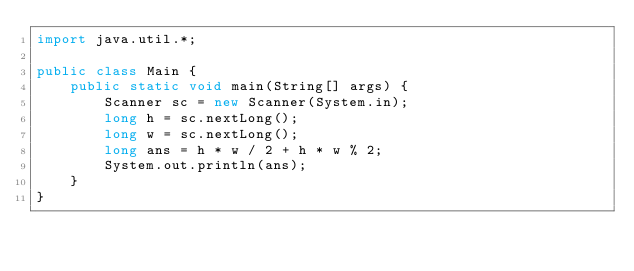Convert code to text. <code><loc_0><loc_0><loc_500><loc_500><_Java_>import java.util.*;

public class Main {
    public static void main(String[] args) {
        Scanner sc = new Scanner(System.in);
        long h = sc.nextLong();
        long w = sc.nextLong();
        long ans = h * w / 2 + h * w % 2;
        System.out.println(ans);
    }
}</code> 